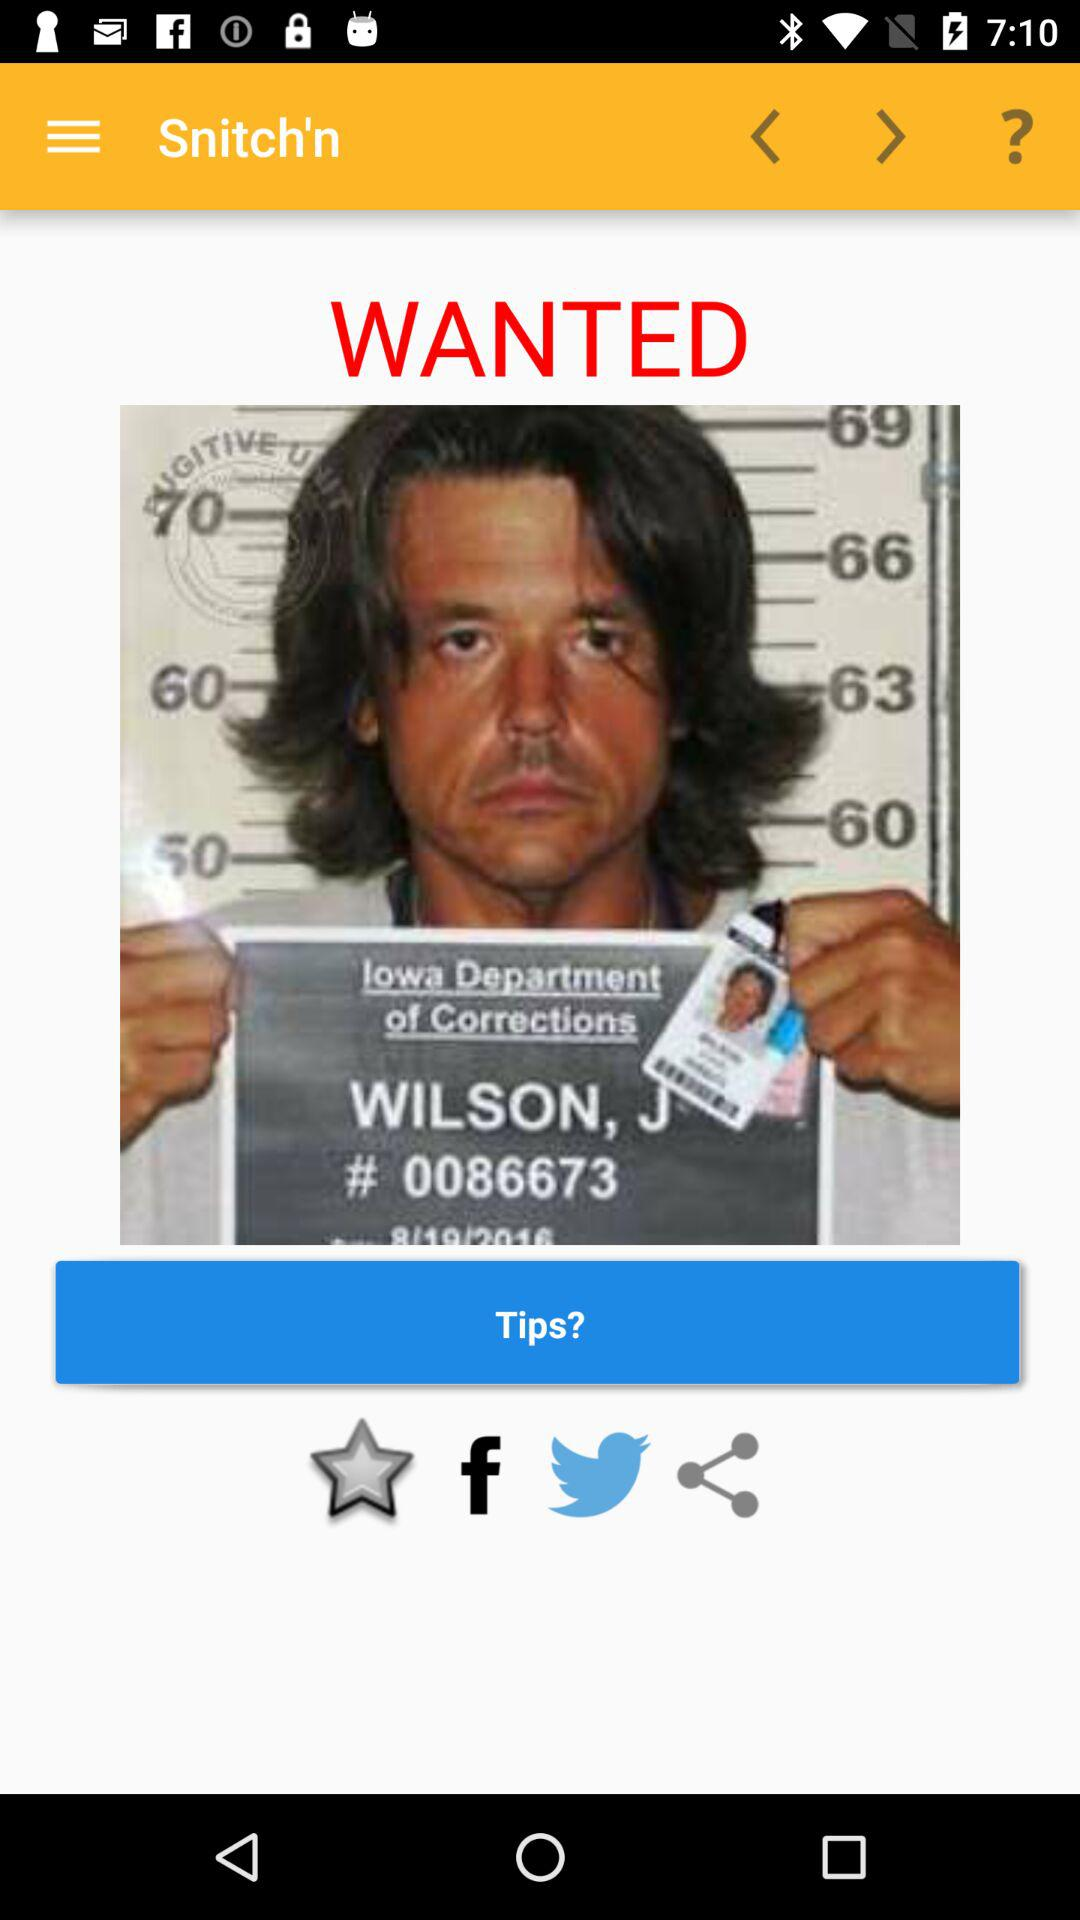What is the name of this person? The name of the person is Wilson, J. 